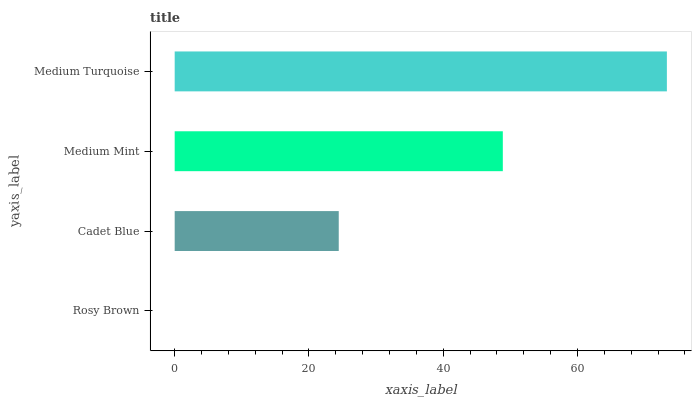Is Rosy Brown the minimum?
Answer yes or no. Yes. Is Medium Turquoise the maximum?
Answer yes or no. Yes. Is Cadet Blue the minimum?
Answer yes or no. No. Is Cadet Blue the maximum?
Answer yes or no. No. Is Cadet Blue greater than Rosy Brown?
Answer yes or no. Yes. Is Rosy Brown less than Cadet Blue?
Answer yes or no. Yes. Is Rosy Brown greater than Cadet Blue?
Answer yes or no. No. Is Cadet Blue less than Rosy Brown?
Answer yes or no. No. Is Medium Mint the high median?
Answer yes or no. Yes. Is Cadet Blue the low median?
Answer yes or no. Yes. Is Rosy Brown the high median?
Answer yes or no. No. Is Medium Mint the low median?
Answer yes or no. No. 